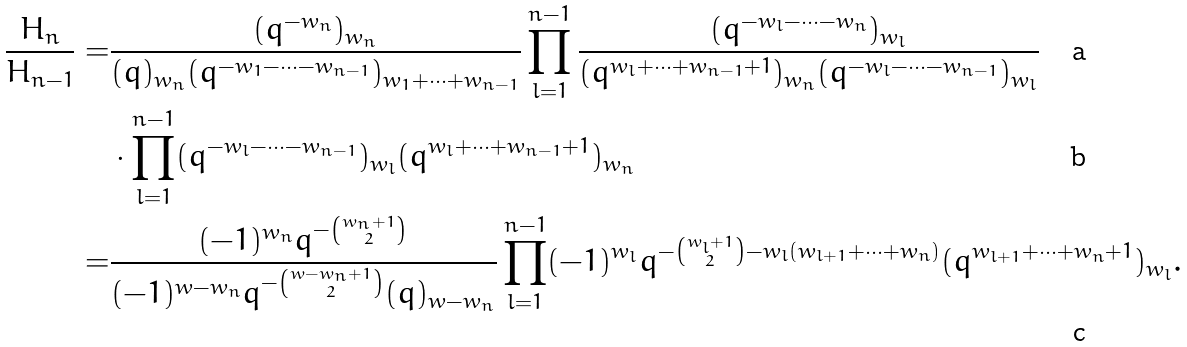<formula> <loc_0><loc_0><loc_500><loc_500>\frac { H _ { n } } { H _ { n - 1 } } = & \frac { ( q ^ { - w _ { n } } ) _ { w _ { n } } } { ( q ) _ { w _ { n } } ( q ^ { - w _ { 1 } - \cdots - w _ { n - 1 } } ) _ { w _ { 1 } + \cdots + w _ { n - 1 } } } \prod _ { l = 1 } ^ { n - 1 } \frac { ( q ^ { - w _ { l } - \cdots - w _ { n } } ) _ { w _ { l } } } { ( q ^ { w _ { l } + \cdots + w _ { n - 1 } + 1 } ) _ { w _ { n } } ( q ^ { - w _ { l } - \cdots - w _ { n - 1 } } ) _ { w _ { l } } } \\ & \cdot \prod _ { l = 1 } ^ { n - 1 } ( q ^ { - w _ { l } - \cdots - w _ { n - 1 } } ) _ { w _ { l } } ( q ^ { w _ { l } + \cdots + w _ { n - 1 } + 1 } ) _ { w _ { n } } \\ = & \frac { ( - 1 ) ^ { w _ { n } } q ^ { - { w _ { n } + 1 \choose 2 } } } { ( - 1 ) ^ { w - w _ { n } } q ^ { - { w - w _ { n } + 1 \choose 2 } } ( q ) _ { w - w _ { n } } } \prod _ { l = 1 } ^ { n - 1 } ( - 1 ) ^ { w _ { l } } q ^ { - { w _ { l } + 1 \choose 2 } - w _ { l } ( w _ { l + 1 } + \cdots + w _ { n } ) } ( q ^ { w _ { l + 1 } + \cdots + w _ { n } + 1 } ) _ { w _ { l } } .</formula> 